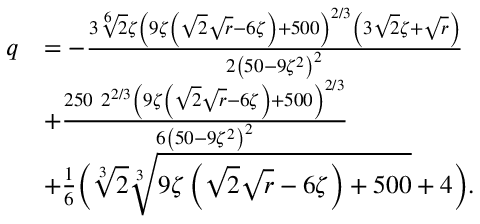Convert formula to latex. <formula><loc_0><loc_0><loc_500><loc_500>\begin{array} { r l } { q } & { = - \frac { 3 \sqrt { [ } 6 ] { 2 } \zeta \left ( 9 \zeta \left ( \sqrt { 2 } \sqrt { r } - 6 \zeta \right ) + 5 0 0 \right ) ^ { 2 / 3 } \left ( 3 \sqrt { 2 } \zeta + \sqrt { r } \right ) } { 2 \left ( 5 0 - 9 \zeta ^ { 2 } \right ) ^ { 2 } } } \\ & { + \frac { 2 5 0 \ 2 ^ { 2 / 3 } \left ( 9 \zeta \left ( \sqrt { 2 } \sqrt { r } - 6 \zeta \right ) + 5 0 0 \right ) ^ { 2 / 3 } } { 6 \left ( 5 0 - 9 \zeta ^ { 2 } \right ) ^ { 2 } } } \\ & { + \frac { 1 } { 6 } \left ( \sqrt { [ } 3 ] { 2 } \sqrt { [ } 3 ] { 9 \zeta \left ( \sqrt { 2 } \sqrt { r } - 6 \zeta \right ) + 5 0 0 } + 4 \right ) . } \end{array}</formula> 